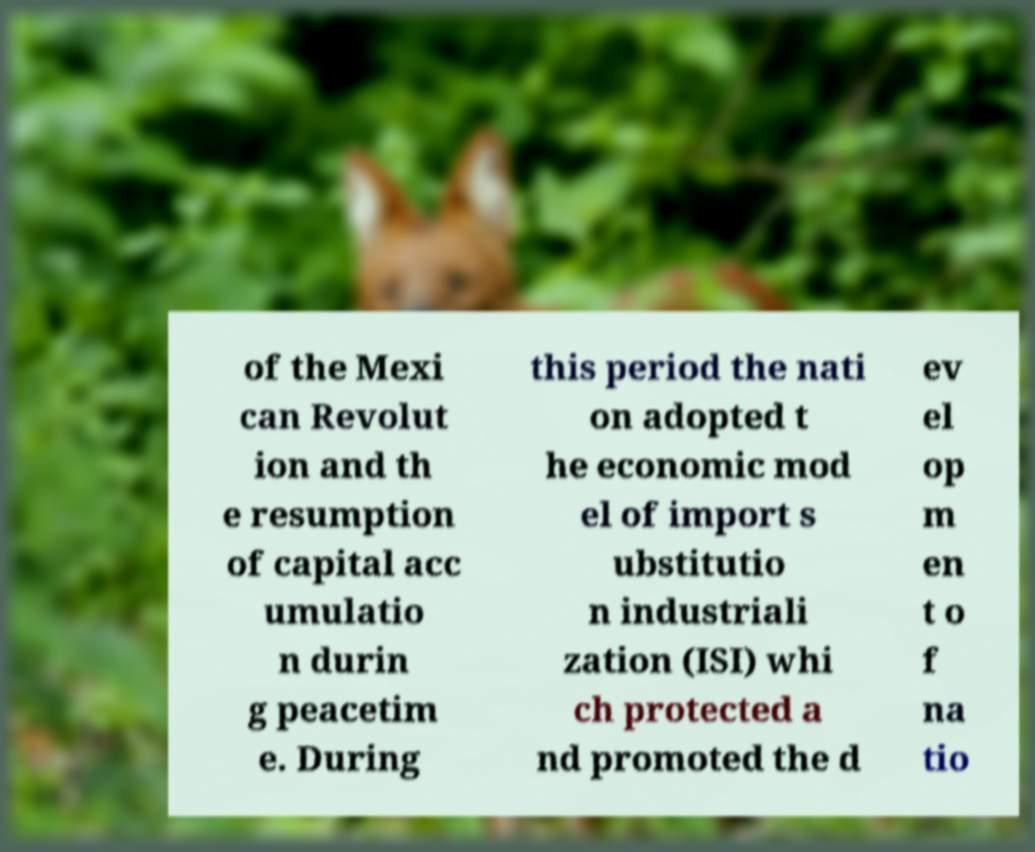Please read and relay the text visible in this image. What does it say? of the Mexi can Revolut ion and th e resumption of capital acc umulatio n durin g peacetim e. During this period the nati on adopted t he economic mod el of import s ubstitutio n industriali zation (ISI) whi ch protected a nd promoted the d ev el op m en t o f na tio 